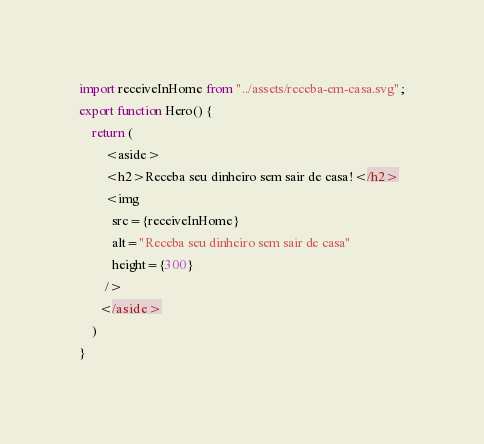<code> <loc_0><loc_0><loc_500><loc_500><_TypeScript_>import receiveInHome from "../assets/receba-em-casa.svg";
export function Hero() {
    return (
        <aside>
        <h2>Receba seu dinheiro sem sair de casa!</h2>
        <img
          src={receiveInHome}
          alt="Receba seu dinheiro sem sair de casa"
          height={300}
        />
      </aside>
    )
}</code> 